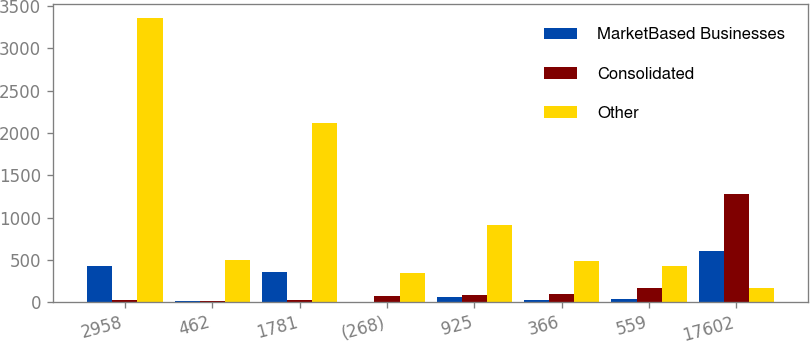<chart> <loc_0><loc_0><loc_500><loc_500><stacked_bar_chart><ecel><fcel>2958<fcel>462<fcel>1781<fcel>(268)<fcel>925<fcel>366<fcel>559<fcel>17602<nl><fcel>MarketBased Businesses<fcel>422<fcel>18<fcel>360<fcel>3<fcel>66<fcel>28<fcel>38<fcel>599<nl><fcel>Consolidated<fcel>23<fcel>12<fcel>28<fcel>77<fcel>79<fcel>92<fcel>171<fcel>1281<nl><fcel>Other<fcel>3357<fcel>492<fcel>2113<fcel>342<fcel>912<fcel>486<fcel>426<fcel>171<nl></chart> 